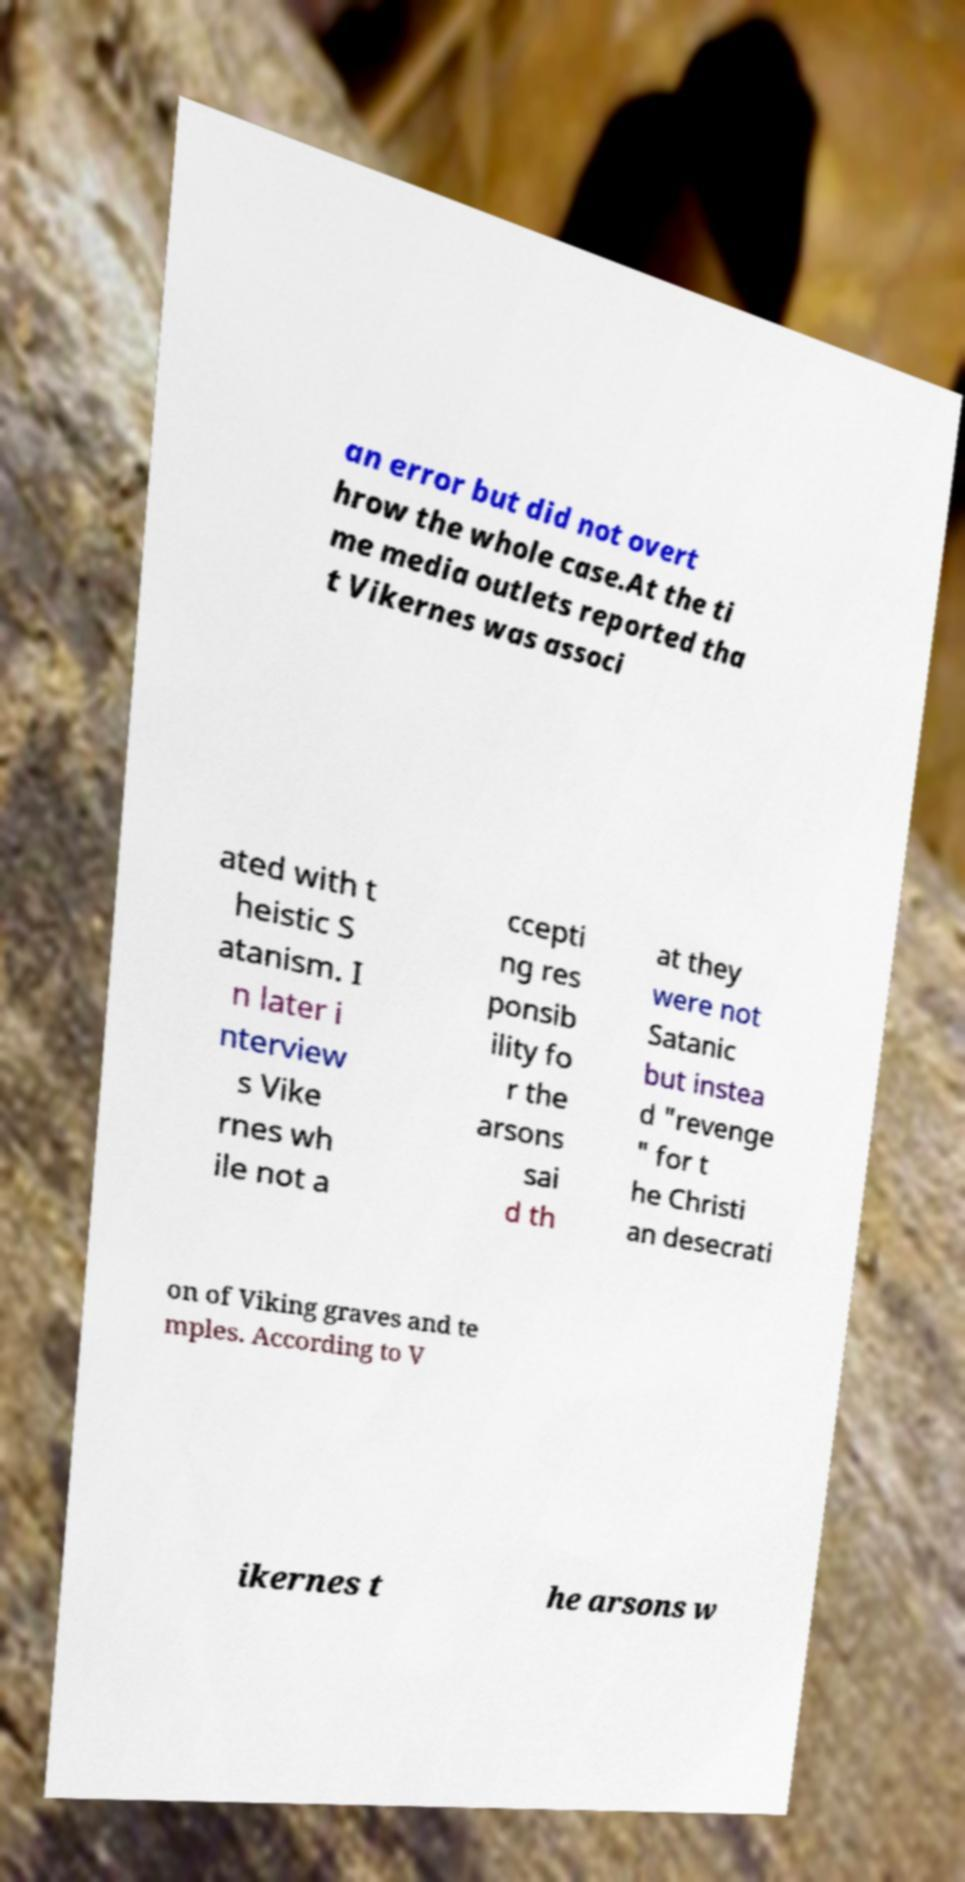I need the written content from this picture converted into text. Can you do that? an error but did not overt hrow the whole case.At the ti me media outlets reported tha t Vikernes was associ ated with t heistic S atanism. I n later i nterview s Vike rnes wh ile not a ccepti ng res ponsib ility fo r the arsons sai d th at they were not Satanic but instea d "revenge " for t he Christi an desecrati on of Viking graves and te mples. According to V ikernes t he arsons w 